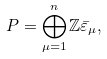Convert formula to latex. <formula><loc_0><loc_0><loc_500><loc_500>P = \bigoplus _ { \mu = 1 } ^ { n } \mathbb { Z } \bar { \varepsilon } _ { \mu } ,</formula> 